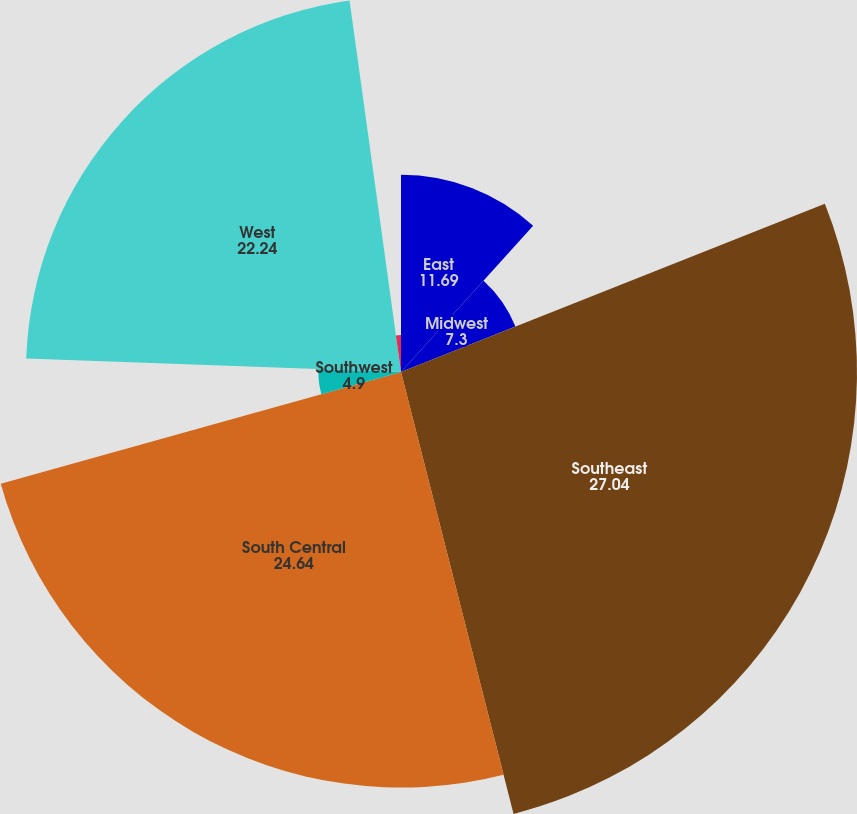Convert chart. <chart><loc_0><loc_0><loc_500><loc_500><pie_chart><fcel>East<fcel>Midwest<fcel>Southeast<fcel>South Central<fcel>Southwest<fcel>West<fcel>Corporate and unallocated (2)<nl><fcel>11.69%<fcel>7.3%<fcel>27.04%<fcel>24.64%<fcel>4.9%<fcel>22.24%<fcel>2.19%<nl></chart> 